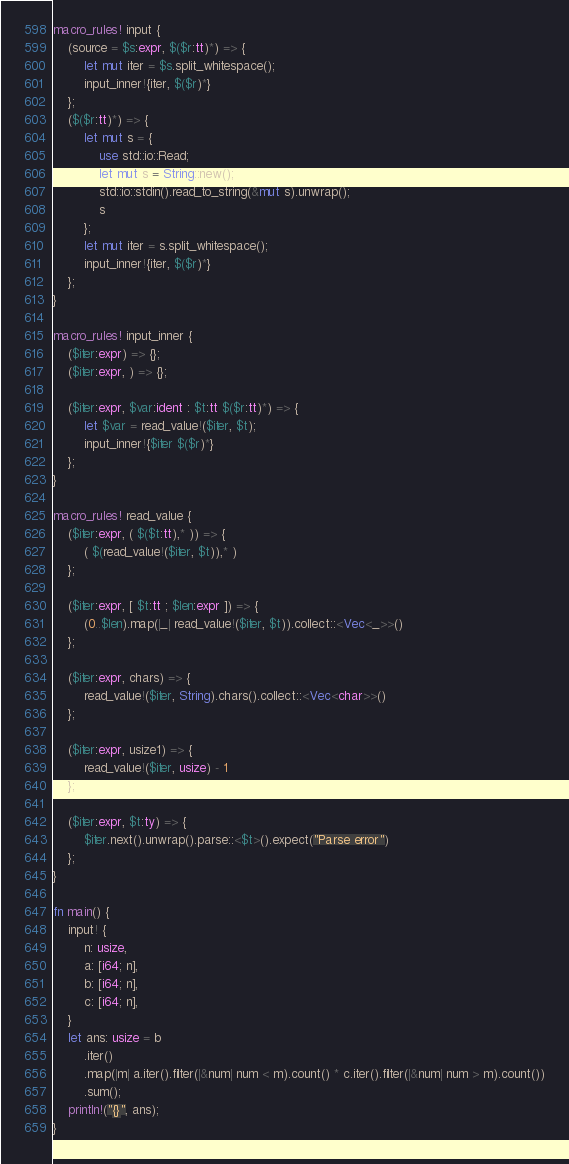<code> <loc_0><loc_0><loc_500><loc_500><_Rust_>macro_rules! input {
    (source = $s:expr, $($r:tt)*) => {
        let mut iter = $s.split_whitespace();
        input_inner!{iter, $($r)*}
    };
    ($($r:tt)*) => {
        let mut s = {
            use std::io::Read;
            let mut s = String::new();
            std::io::stdin().read_to_string(&mut s).unwrap();
            s
        };
        let mut iter = s.split_whitespace();
        input_inner!{iter, $($r)*}
    };
}

macro_rules! input_inner {
    ($iter:expr) => {};
    ($iter:expr, ) => {};

    ($iter:expr, $var:ident : $t:tt $($r:tt)*) => {
        let $var = read_value!($iter, $t);
        input_inner!{$iter $($r)*}
    };
}

macro_rules! read_value {
    ($iter:expr, ( $($t:tt),* )) => {
        ( $(read_value!($iter, $t)),* )
    };

    ($iter:expr, [ $t:tt ; $len:expr ]) => {
        (0..$len).map(|_| read_value!($iter, $t)).collect::<Vec<_>>()
    };

    ($iter:expr, chars) => {
        read_value!($iter, String).chars().collect::<Vec<char>>()
    };

    ($iter:expr, usize1) => {
        read_value!($iter, usize) - 1
    };

    ($iter:expr, $t:ty) => {
        $iter.next().unwrap().parse::<$t>().expect("Parse error")
    };
}

fn main() {
    input! {
        n: usize,
        a: [i64; n],
        b: [i64; n],
        c: [i64; n],
    }
    let ans: usize = b
        .iter()
        .map(|m| a.iter().filter(|&num| num < m).count() * c.iter().filter(|&num| num > m).count())
        .sum();
    println!("{}", ans);
}
</code> 